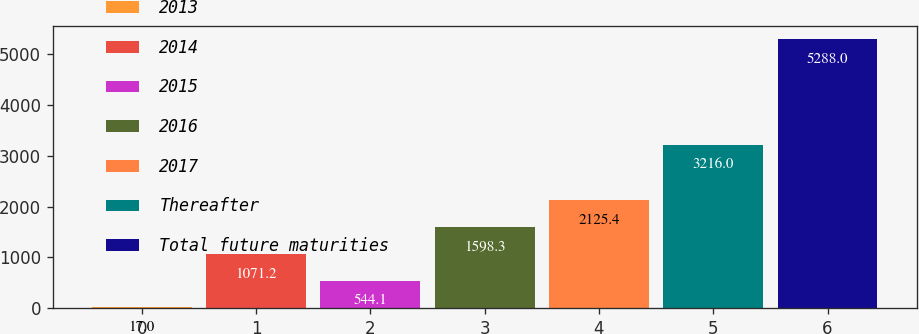Convert chart. <chart><loc_0><loc_0><loc_500><loc_500><bar_chart><fcel>2013<fcel>2014<fcel>2015<fcel>2016<fcel>2017<fcel>Thereafter<fcel>Total future maturities<nl><fcel>17<fcel>1071.2<fcel>544.1<fcel>1598.3<fcel>2125.4<fcel>3216<fcel>5288<nl></chart> 